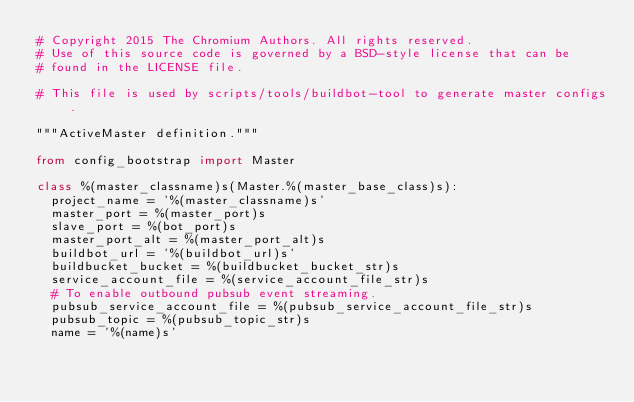<code> <loc_0><loc_0><loc_500><loc_500><_Python_># Copyright 2015 The Chromium Authors. All rights reserved.
# Use of this source code is governed by a BSD-style license that can be
# found in the LICENSE file.

# This file is used by scripts/tools/buildbot-tool to generate master configs.

"""ActiveMaster definition."""

from config_bootstrap import Master

class %(master_classname)s(Master.%(master_base_class)s):
  project_name = '%(master_classname)s'
  master_port = %(master_port)s
  slave_port = %(bot_port)s
  master_port_alt = %(master_port_alt)s
  buildbot_url = '%(buildbot_url)s'
  buildbucket_bucket = %(buildbucket_bucket_str)s
  service_account_file = %(service_account_file_str)s
  # To enable outbound pubsub event streaming.
  pubsub_service_account_file = %(pubsub_service_account_file_str)s
  pubsub_topic = %(pubsub_topic_str)s
  name = '%(name)s'
</code> 